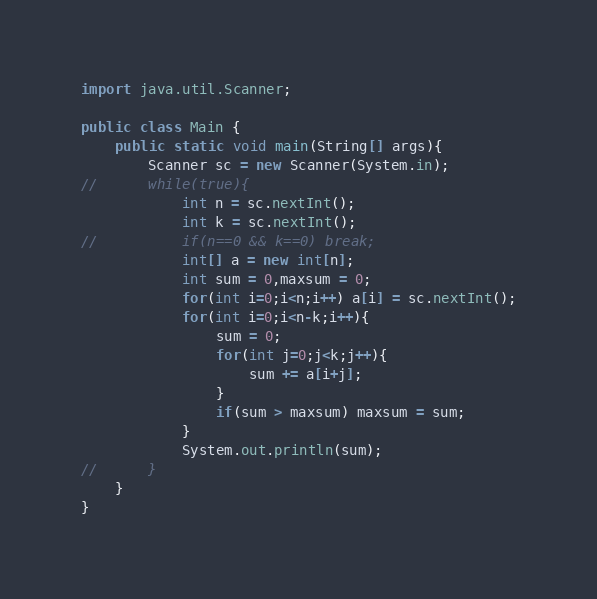<code> <loc_0><loc_0><loc_500><loc_500><_Java_>import java.util.Scanner;

public class Main {
	public static void main(String[] args){
		Scanner sc = new Scanner(System.in);
//		while(true){
			int n = sc.nextInt();
			int k = sc.nextInt();
//			if(n==0 && k==0) break;
			int[] a = new int[n];
			int sum = 0,maxsum = 0;
			for(int i=0;i<n;i++) a[i] = sc.nextInt();
			for(int i=0;i<n-k;i++){
				sum = 0;
				for(int j=0;j<k;j++){
					sum += a[i+j];
				}
				if(sum > maxsum) maxsum = sum;
			}
			System.out.println(sum);
//		}
	}
}</code> 